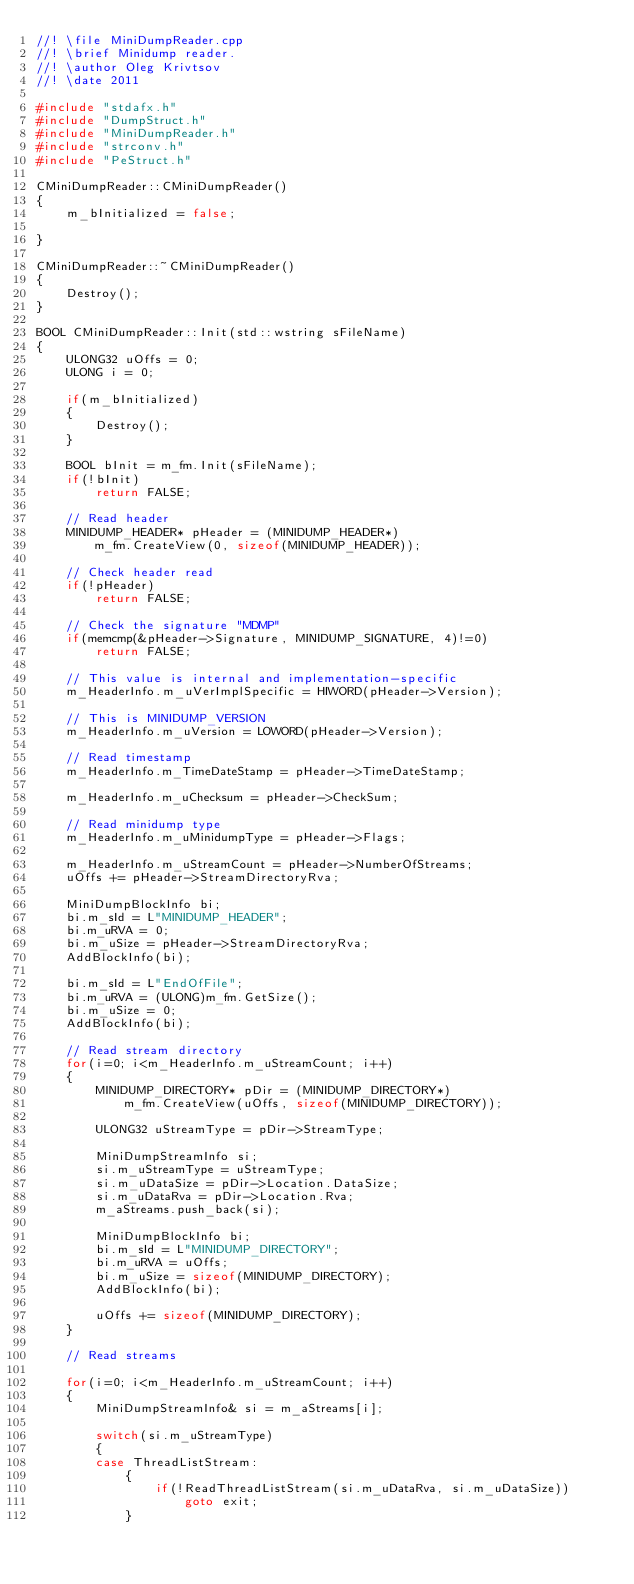Convert code to text. <code><loc_0><loc_0><loc_500><loc_500><_C++_>//! \file MiniDumpReader.cpp
//! \brief Minidump reader.
//! \author Oleg Krivtsov
//! \date 2011

#include "stdafx.h"
#include "DumpStruct.h"
#include "MiniDumpReader.h"
#include "strconv.h"
#include "PeStruct.h"

CMiniDumpReader::CMiniDumpReader()
{
    m_bInitialized = false;

}

CMiniDumpReader::~CMiniDumpReader()
{
    Destroy();
}

BOOL CMiniDumpReader::Init(std::wstring sFileName)
{
    ULONG32 uOffs = 0;
    ULONG i = 0;

    if(m_bInitialized)
    {
        Destroy();
    }

    BOOL bInit = m_fm.Init(sFileName);
    if(!bInit)
        return FALSE;

	// Read header
    MINIDUMP_HEADER* pHeader = (MINIDUMP_HEADER*)
        m_fm.CreateView(0, sizeof(MINIDUMP_HEADER));

	// Check header read
	if(!pHeader)
		return FALSE;

    // Check the signature "MDMP"
    if(memcmp(&pHeader->Signature, MINIDUMP_SIGNATURE, 4)!=0)
        return FALSE;

    // This value is internal and implementation-specific
    m_HeaderInfo.m_uVerImplSpecific = HIWORD(pHeader->Version);

    // This is MINIDUMP_VERSION
    m_HeaderInfo.m_uVersion = LOWORD(pHeader->Version);

    // Read timestamp
    m_HeaderInfo.m_TimeDateStamp = pHeader->TimeDateStamp;

    m_HeaderInfo.m_uChecksum = pHeader->CheckSum;

    // Read minidump type
    m_HeaderInfo.m_uMinidumpType = pHeader->Flags;

    m_HeaderInfo.m_uStreamCount = pHeader->NumberOfStreams;
    uOffs += pHeader->StreamDirectoryRva;

    MiniDumpBlockInfo bi;
    bi.m_sId = L"MINIDUMP_HEADER";
    bi.m_uRVA = 0;
    bi.m_uSize = pHeader->StreamDirectoryRva;
    AddBlockInfo(bi);

    bi.m_sId = L"EndOfFile";
    bi.m_uRVA = (ULONG)m_fm.GetSize();
    bi.m_uSize = 0;
    AddBlockInfo(bi);

    // Read stream directory
    for(i=0; i<m_HeaderInfo.m_uStreamCount; i++)
    {
        MINIDUMP_DIRECTORY* pDir = (MINIDUMP_DIRECTORY*)
            m_fm.CreateView(uOffs, sizeof(MINIDUMP_DIRECTORY));

        ULONG32 uStreamType = pDir->StreamType;

        MiniDumpStreamInfo si;
        si.m_uStreamType = uStreamType;
        si.m_uDataSize = pDir->Location.DataSize;
        si.m_uDataRva = pDir->Location.Rva;
        m_aStreams.push_back(si);

        MiniDumpBlockInfo bi;
        bi.m_sId = L"MINIDUMP_DIRECTORY";
        bi.m_uRVA = uOffs;
        bi.m_uSize = sizeof(MINIDUMP_DIRECTORY);
        AddBlockInfo(bi);

        uOffs += sizeof(MINIDUMP_DIRECTORY);
    }

    // Read streams

    for(i=0; i<m_HeaderInfo.m_uStreamCount; i++)
    {
        MiniDumpStreamInfo& si = m_aStreams[i];

        switch(si.m_uStreamType)
        {
        case ThreadListStream:
            {
                if(!ReadThreadListStream(si.m_uDataRva, si.m_uDataSize))
					goto exit;
            }</code> 